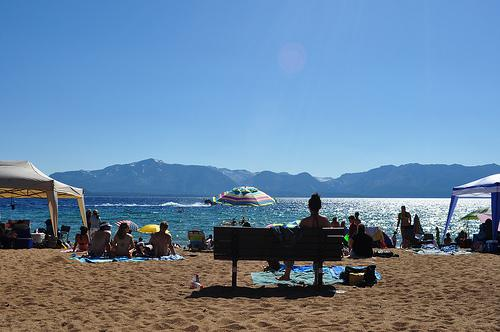Question: who is sitting on the bench?
Choices:
A. A man.
B. A Woman.
C. A boy.
D. A girl.
Answer with the letter. Answer: B Question: when is this picture taken?
Choices:
A. 8pm.
B. At night.
C. Summer.
D. During the day.
Answer with the letter. Answer: C Question: where was this picture taken?
Choices:
A. The mountains.
B. The Beach.
C. A farm.
D. A schoolyard.
Answer with the letter. Answer: B Question: how many people are sitting on the bench?
Choices:
A. One.
B. Two.
C. Three.
D. Four.
Answer with the letter. Answer: A Question: what color is the sky in this picture?
Choices:
A. Blue.
B. Gray.
C. Pink.
D. White.
Answer with the letter. Answer: A Question: how many tents can be seen in this picture?
Choices:
A. Two.
B. One.
C. Three.
D. Four.
Answer with the letter. Answer: A Question: what color is the sand on this beach?
Choices:
A. Yellow.
B. Brown.
C. White.
D. Black.
Answer with the letter. Answer: B 